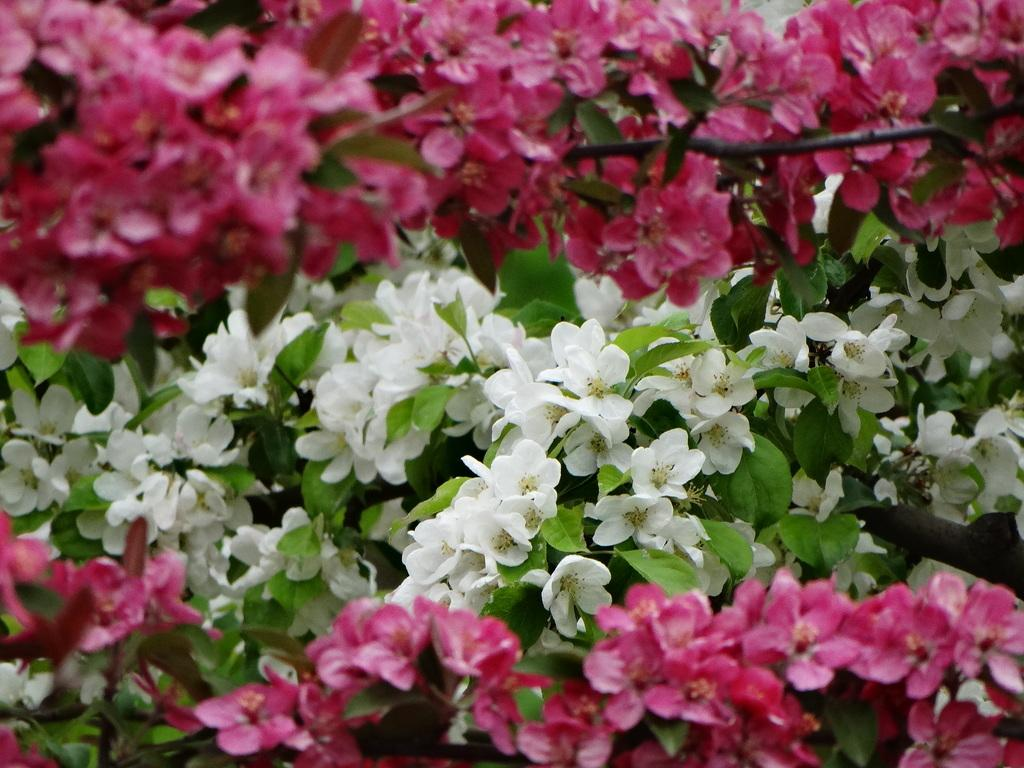What is the main subject of the image? The main subject of the image is a group of plants. What specific feature do the plants have? The plants have flowers. What colors are the flowers? The flowers are pink and white in color. How many snails can be seen crawling on the flowers in the image? There are no snails visible in the image; it only features a group of plants with flowers. What type of currency is present in the image? There is no currency present in the image; it only features a group of plants with flowers. 